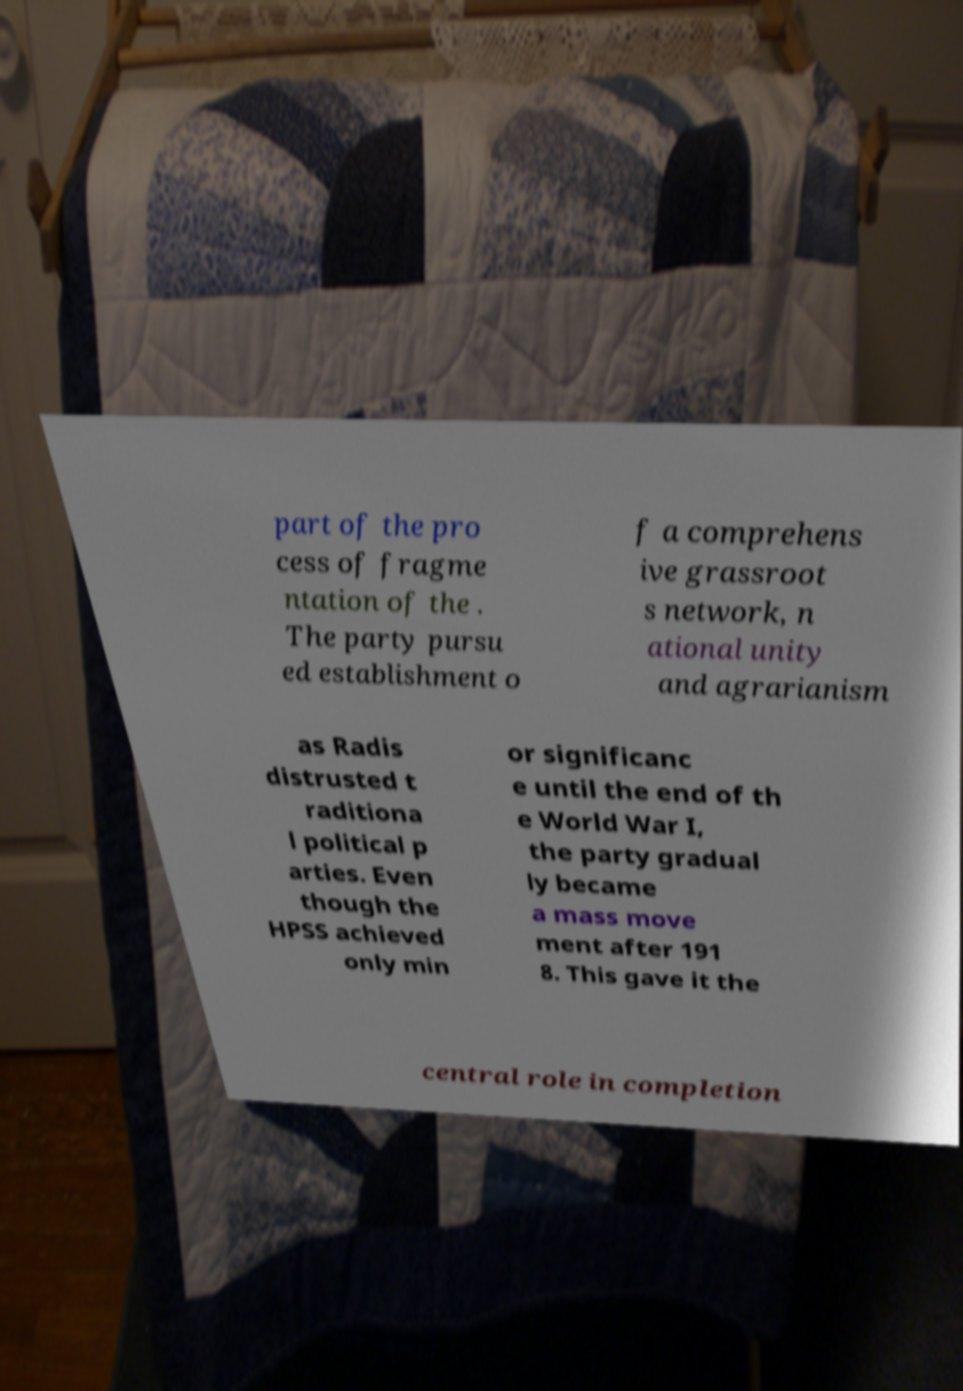Please identify and transcribe the text found in this image. part of the pro cess of fragme ntation of the . The party pursu ed establishment o f a comprehens ive grassroot s network, n ational unity and agrarianism as Radis distrusted t raditiona l political p arties. Even though the HPSS achieved only min or significanc e until the end of th e World War I, the party gradual ly became a mass move ment after 191 8. This gave it the central role in completion 